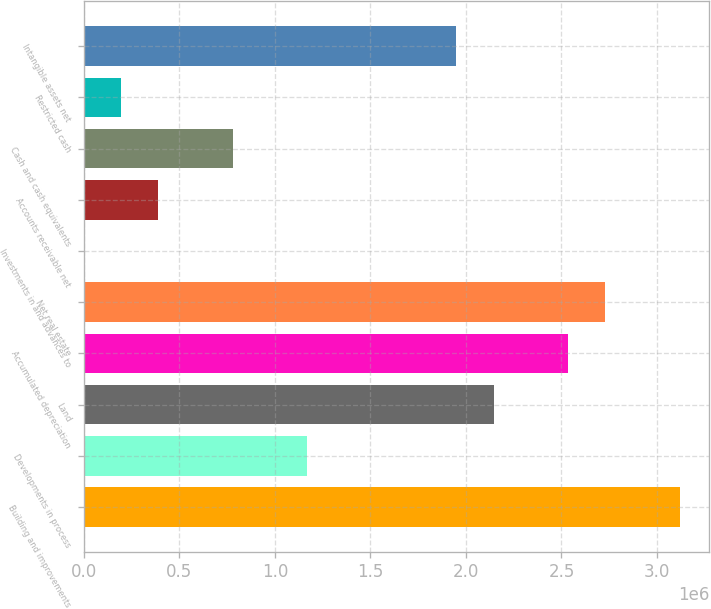<chart> <loc_0><loc_0><loc_500><loc_500><bar_chart><fcel>Building and improvements<fcel>Developments in process<fcel>Land<fcel>Accumulated depreciation<fcel>Net real estate<fcel>Investments in and advances to<fcel>Accounts receivable net<fcel>Cash and cash equivalents<fcel>Restricted cash<fcel>Intangible assets net<nl><fcel>3.1184e+06<fcel>1.17037e+06<fcel>2.14439e+06<fcel>2.53399e+06<fcel>2.72879e+06<fcel>1550<fcel>391156<fcel>780763<fcel>196353<fcel>1.94958e+06<nl></chart> 